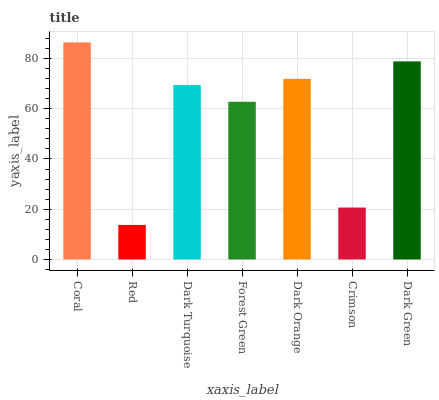Is Red the minimum?
Answer yes or no. Yes. Is Coral the maximum?
Answer yes or no. Yes. Is Dark Turquoise the minimum?
Answer yes or no. No. Is Dark Turquoise the maximum?
Answer yes or no. No. Is Dark Turquoise greater than Red?
Answer yes or no. Yes. Is Red less than Dark Turquoise?
Answer yes or no. Yes. Is Red greater than Dark Turquoise?
Answer yes or no. No. Is Dark Turquoise less than Red?
Answer yes or no. No. Is Dark Turquoise the high median?
Answer yes or no. Yes. Is Dark Turquoise the low median?
Answer yes or no. Yes. Is Red the high median?
Answer yes or no. No. Is Crimson the low median?
Answer yes or no. No. 